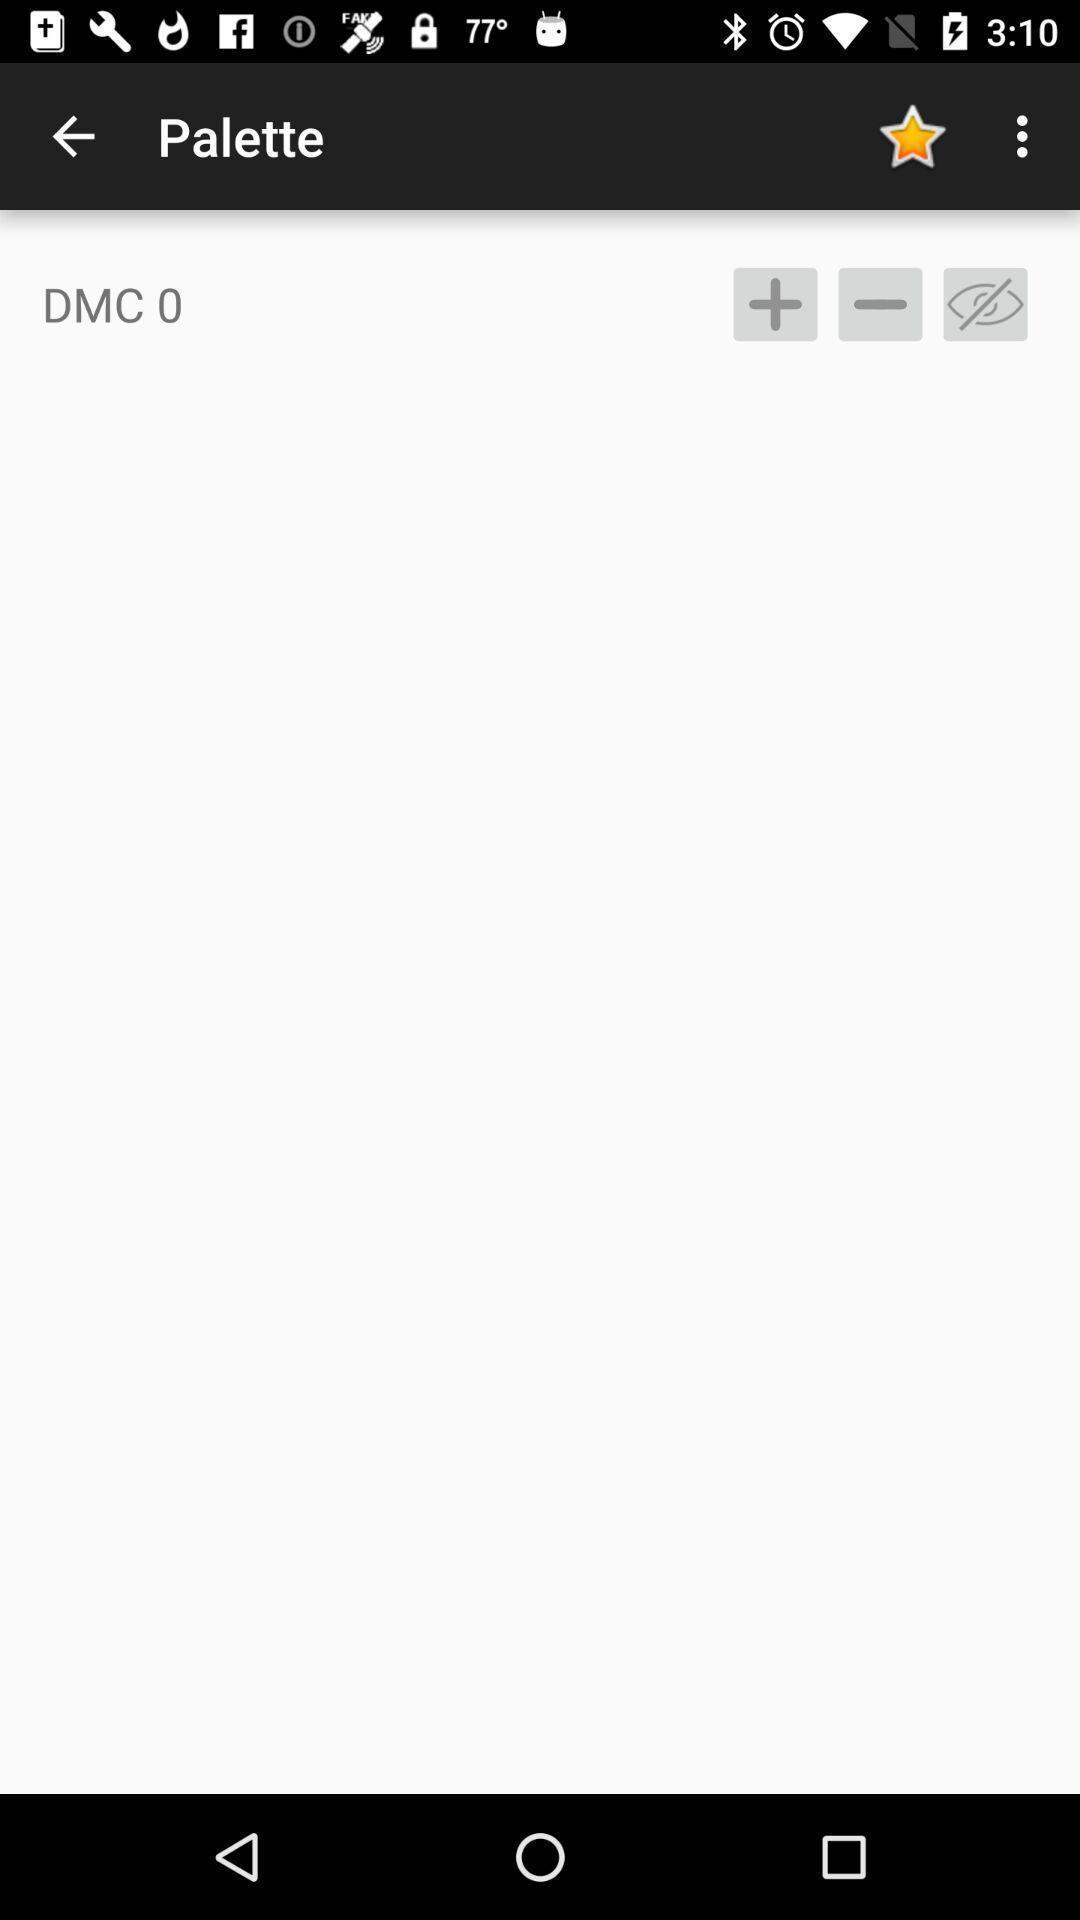Give me a summary of this screen capture. Screen displaying the palette page. 